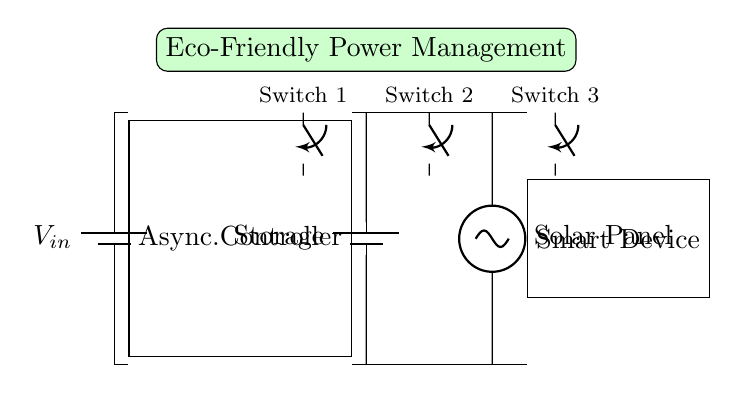What is the main function of the asynchronous controller? The asynchronous controller manages the power distribution from the various sources (battery and solar panel) to the smart device, optimizing energy usage.
Answer: Power management What type of energy source is represented in this circuit? The circuit includes a solar panel as one of its sources, which collects solar energy.
Answer: Solar energy How many switches are present in the circuit diagram? There are three switches shown in the diagram, labeled Switch 1, Switch 2, and Switch 3.
Answer: Three What is the role of the energy storage component? The energy storage component (battery) stores energy collected from the solar panel or the main power source for later use by the smart device.
Answer: Energy storage Which component connects the solar panel to the circuit? The circuit connects the solar panel directly to the load through the asynchronous controller and the energy storage.
Answer: Solar panel What does the eco-friendly label indicate about the circuit? The eco-friendly label suggests that the circuit is designed to utilize renewable sources of energy and enhance energy efficiency.
Answer: Renewable design 